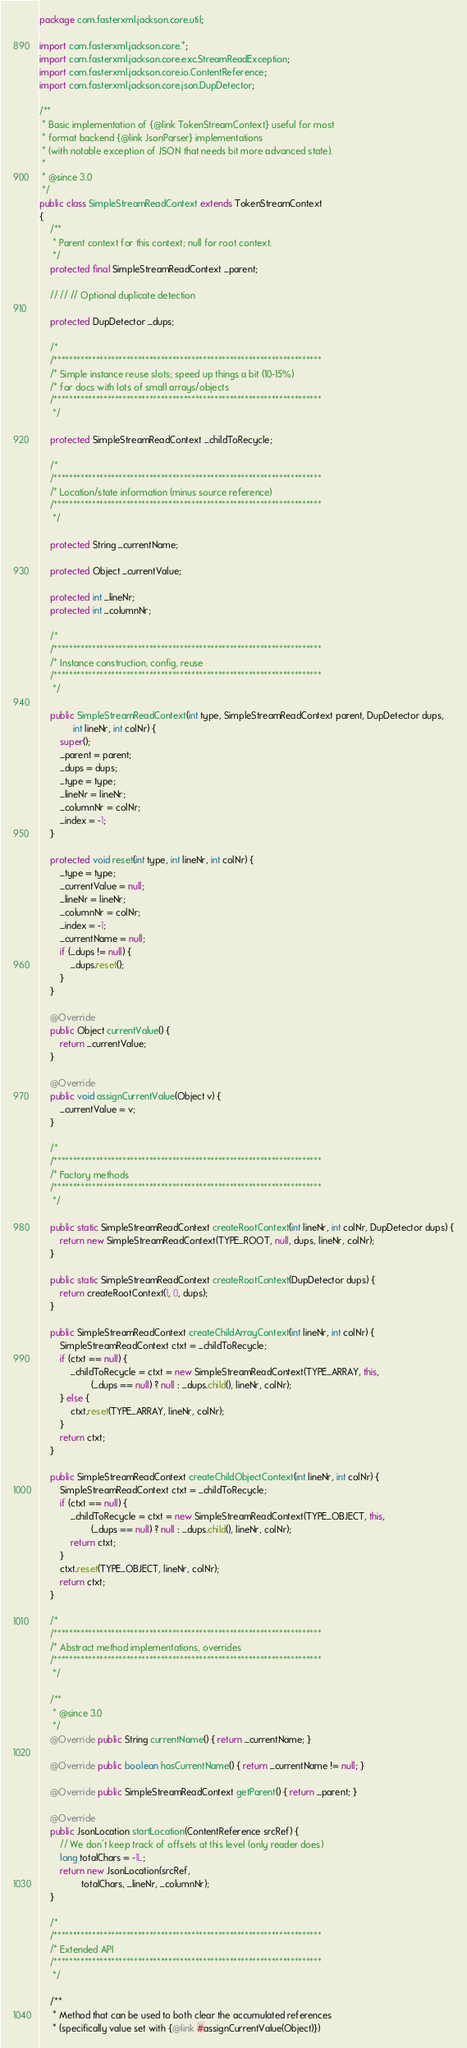<code> <loc_0><loc_0><loc_500><loc_500><_Java_>package com.fasterxml.jackson.core.util;

import com.fasterxml.jackson.core.*;
import com.fasterxml.jackson.core.exc.StreamReadException;
import com.fasterxml.jackson.core.io.ContentReference;
import com.fasterxml.jackson.core.json.DupDetector;

/**
 * Basic implementation of {@link TokenStreamContext} useful for most
 * format backend {@link JsonParser} implementations
 * (with notable exception of JSON that needs bit more advanced state).
 *
 * @since 3.0
 */
public class SimpleStreamReadContext extends TokenStreamContext
{
    /**
     * Parent context for this context; null for root context.
     */
    protected final SimpleStreamReadContext _parent;

    // // // Optional duplicate detection

    protected DupDetector _dups;

    /*
    /**********************************************************************
    /* Simple instance reuse slots; speed up things a bit (10-15%)
    /* for docs with lots of small arrays/objects
    /**********************************************************************
     */

    protected SimpleStreamReadContext _childToRecycle;

    /*
    /**********************************************************************
    /* Location/state information (minus source reference)
    /**********************************************************************
     */

    protected String _currentName;

    protected Object _currentValue;
    
    protected int _lineNr;
    protected int _columnNr;

    /*
    /**********************************************************************
    /* Instance construction, config, reuse
    /**********************************************************************
     */

    public SimpleStreamReadContext(int type, SimpleStreamReadContext parent, DupDetector dups,
             int lineNr, int colNr) {
        super();
        _parent = parent;
        _dups = dups;
        _type = type;
        _lineNr = lineNr;
        _columnNr = colNr;
        _index = -1;
    }

    protected void reset(int type, int lineNr, int colNr) {
        _type = type;
        _currentValue = null;
        _lineNr = lineNr;
        _columnNr = colNr;
        _index = -1;
        _currentName = null;
        if (_dups != null) {
            _dups.reset();
        }
    }

    @Override
    public Object currentValue() {
        return _currentValue;
    }

    @Override
    public void assignCurrentValue(Object v) {
        _currentValue = v;
    }

    /*
    /**********************************************************************
    /* Factory methods
    /**********************************************************************
     */

    public static SimpleStreamReadContext createRootContext(int lineNr, int colNr, DupDetector dups) {
        return new SimpleStreamReadContext(TYPE_ROOT, null, dups, lineNr, colNr);
    }

    public static SimpleStreamReadContext createRootContext(DupDetector dups) {
        return createRootContext(1, 0, dups);
    }
    
    public SimpleStreamReadContext createChildArrayContext(int lineNr, int colNr) {
        SimpleStreamReadContext ctxt = _childToRecycle;
        if (ctxt == null) {
            _childToRecycle = ctxt = new SimpleStreamReadContext(TYPE_ARRAY, this,
                    (_dups == null) ? null : _dups.child(), lineNr, colNr);
        } else {
            ctxt.reset(TYPE_ARRAY, lineNr, colNr);
        }
        return ctxt;
    }

    public SimpleStreamReadContext createChildObjectContext(int lineNr, int colNr) {
        SimpleStreamReadContext ctxt = _childToRecycle;
        if (ctxt == null) {
            _childToRecycle = ctxt = new SimpleStreamReadContext(TYPE_OBJECT, this,
                    (_dups == null) ? null : _dups.child(), lineNr, colNr);
            return ctxt;
        }
        ctxt.reset(TYPE_OBJECT, lineNr, colNr);
        return ctxt;
    }

    /*
    /**********************************************************************
    /* Abstract method implementations, overrides
    /**********************************************************************
     */

    /**
     * @since 3.0
     */
    @Override public String currentName() { return _currentName; }

    @Override public boolean hasCurrentName() { return _currentName != null; }

    @Override public SimpleStreamReadContext getParent() { return _parent; }

    @Override
    public JsonLocation startLocation(ContentReference srcRef) {
        // We don't keep track of offsets at this level (only reader does)
        long totalChars = -1L;
        return new JsonLocation(srcRef,
                totalChars, _lineNr, _columnNr);
    }

    /*
    /**********************************************************************
    /* Extended API
    /**********************************************************************
     */

    /**
     * Method that can be used to both clear the accumulated references
     * (specifically value set with {@link #assignCurrentValue(Object)})</code> 